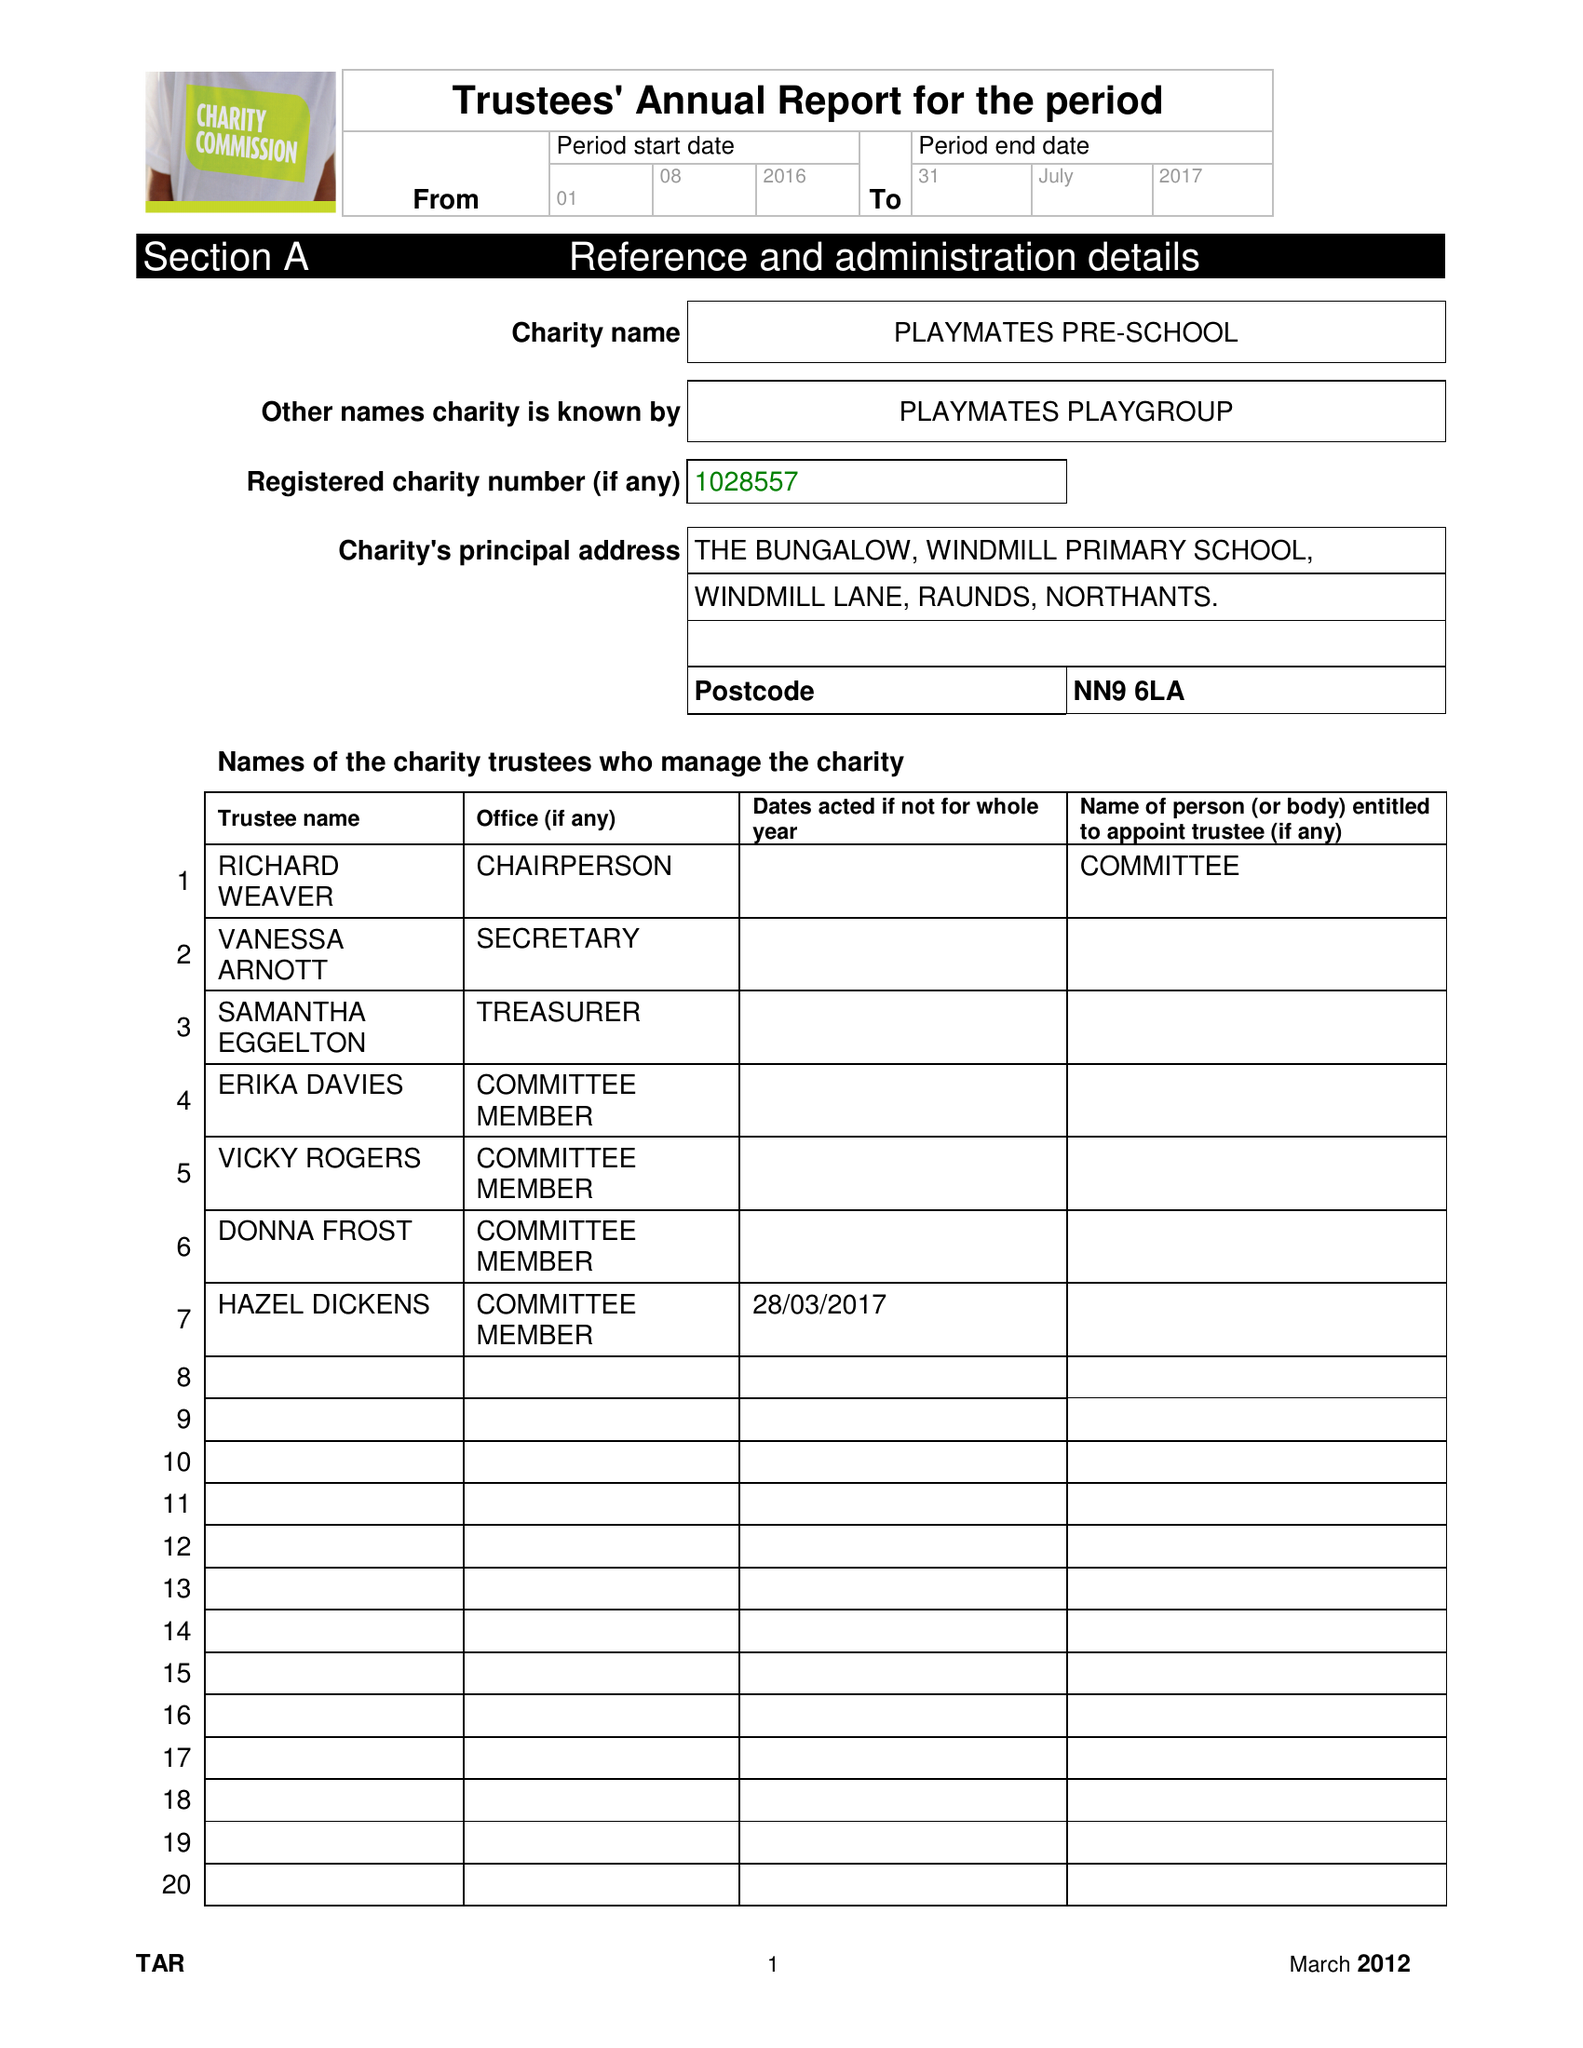What is the value for the address__postcode?
Answer the question using a single word or phrase. NN9 6LA 